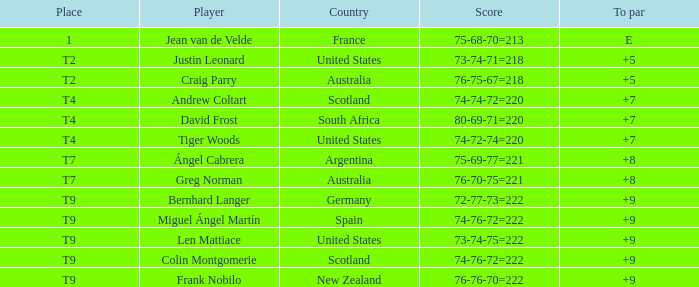Write the full table. {'header': ['Place', 'Player', 'Country', 'Score', 'To par'], 'rows': [['1', 'Jean van de Velde', 'France', '75-68-70=213', 'E'], ['T2', 'Justin Leonard', 'United States', '73-74-71=218', '+5'], ['T2', 'Craig Parry', 'Australia', '76-75-67=218', '+5'], ['T4', 'Andrew Coltart', 'Scotland', '74-74-72=220', '+7'], ['T4', 'David Frost', 'South Africa', '80-69-71=220', '+7'], ['T4', 'Tiger Woods', 'United States', '74-72-74=220', '+7'], ['T7', 'Ángel Cabrera', 'Argentina', '75-69-77=221', '+8'], ['T7', 'Greg Norman', 'Australia', '76-70-75=221', '+8'], ['T9', 'Bernhard Langer', 'Germany', '72-77-73=222', '+9'], ['T9', 'Miguel Ángel Martín', 'Spain', '74-76-72=222', '+9'], ['T9', 'Len Mattiace', 'United States', '73-74-75=222', '+9'], ['T9', 'Colin Montgomerie', 'Scotland', '74-76-72=222', '+9'], ['T9', 'Frank Nobilo', 'New Zealand', '76-76-70=222', '+9']]} Player Craig Parry of Australia is in what place number? T2. 